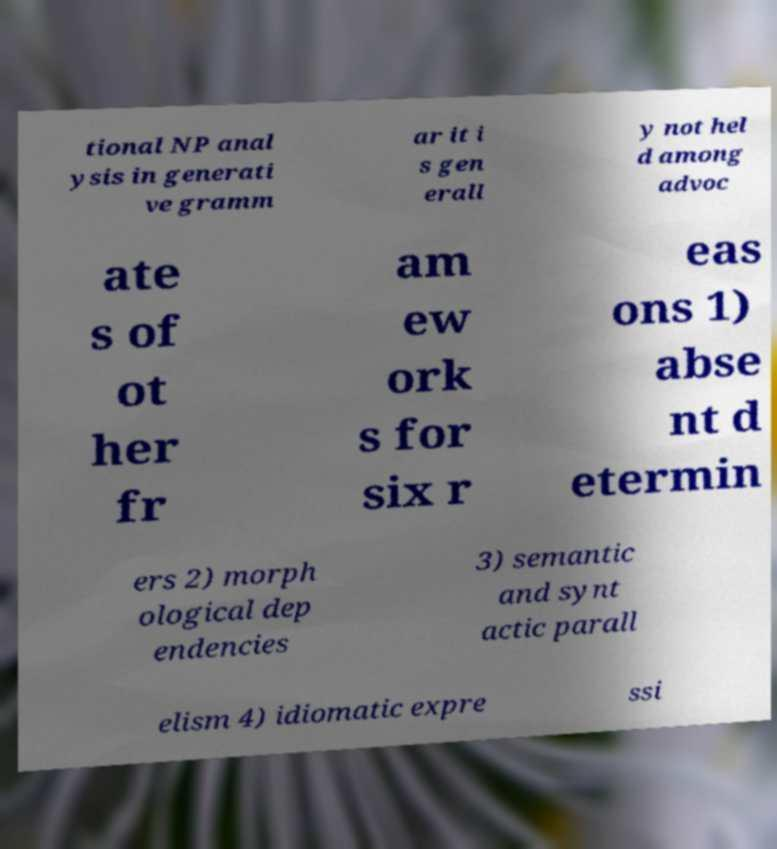Can you read and provide the text displayed in the image?This photo seems to have some interesting text. Can you extract and type it out for me? tional NP anal ysis in generati ve gramm ar it i s gen erall y not hel d among advoc ate s of ot her fr am ew ork s for six r eas ons 1) abse nt d etermin ers 2) morph ological dep endencies 3) semantic and synt actic parall elism 4) idiomatic expre ssi 